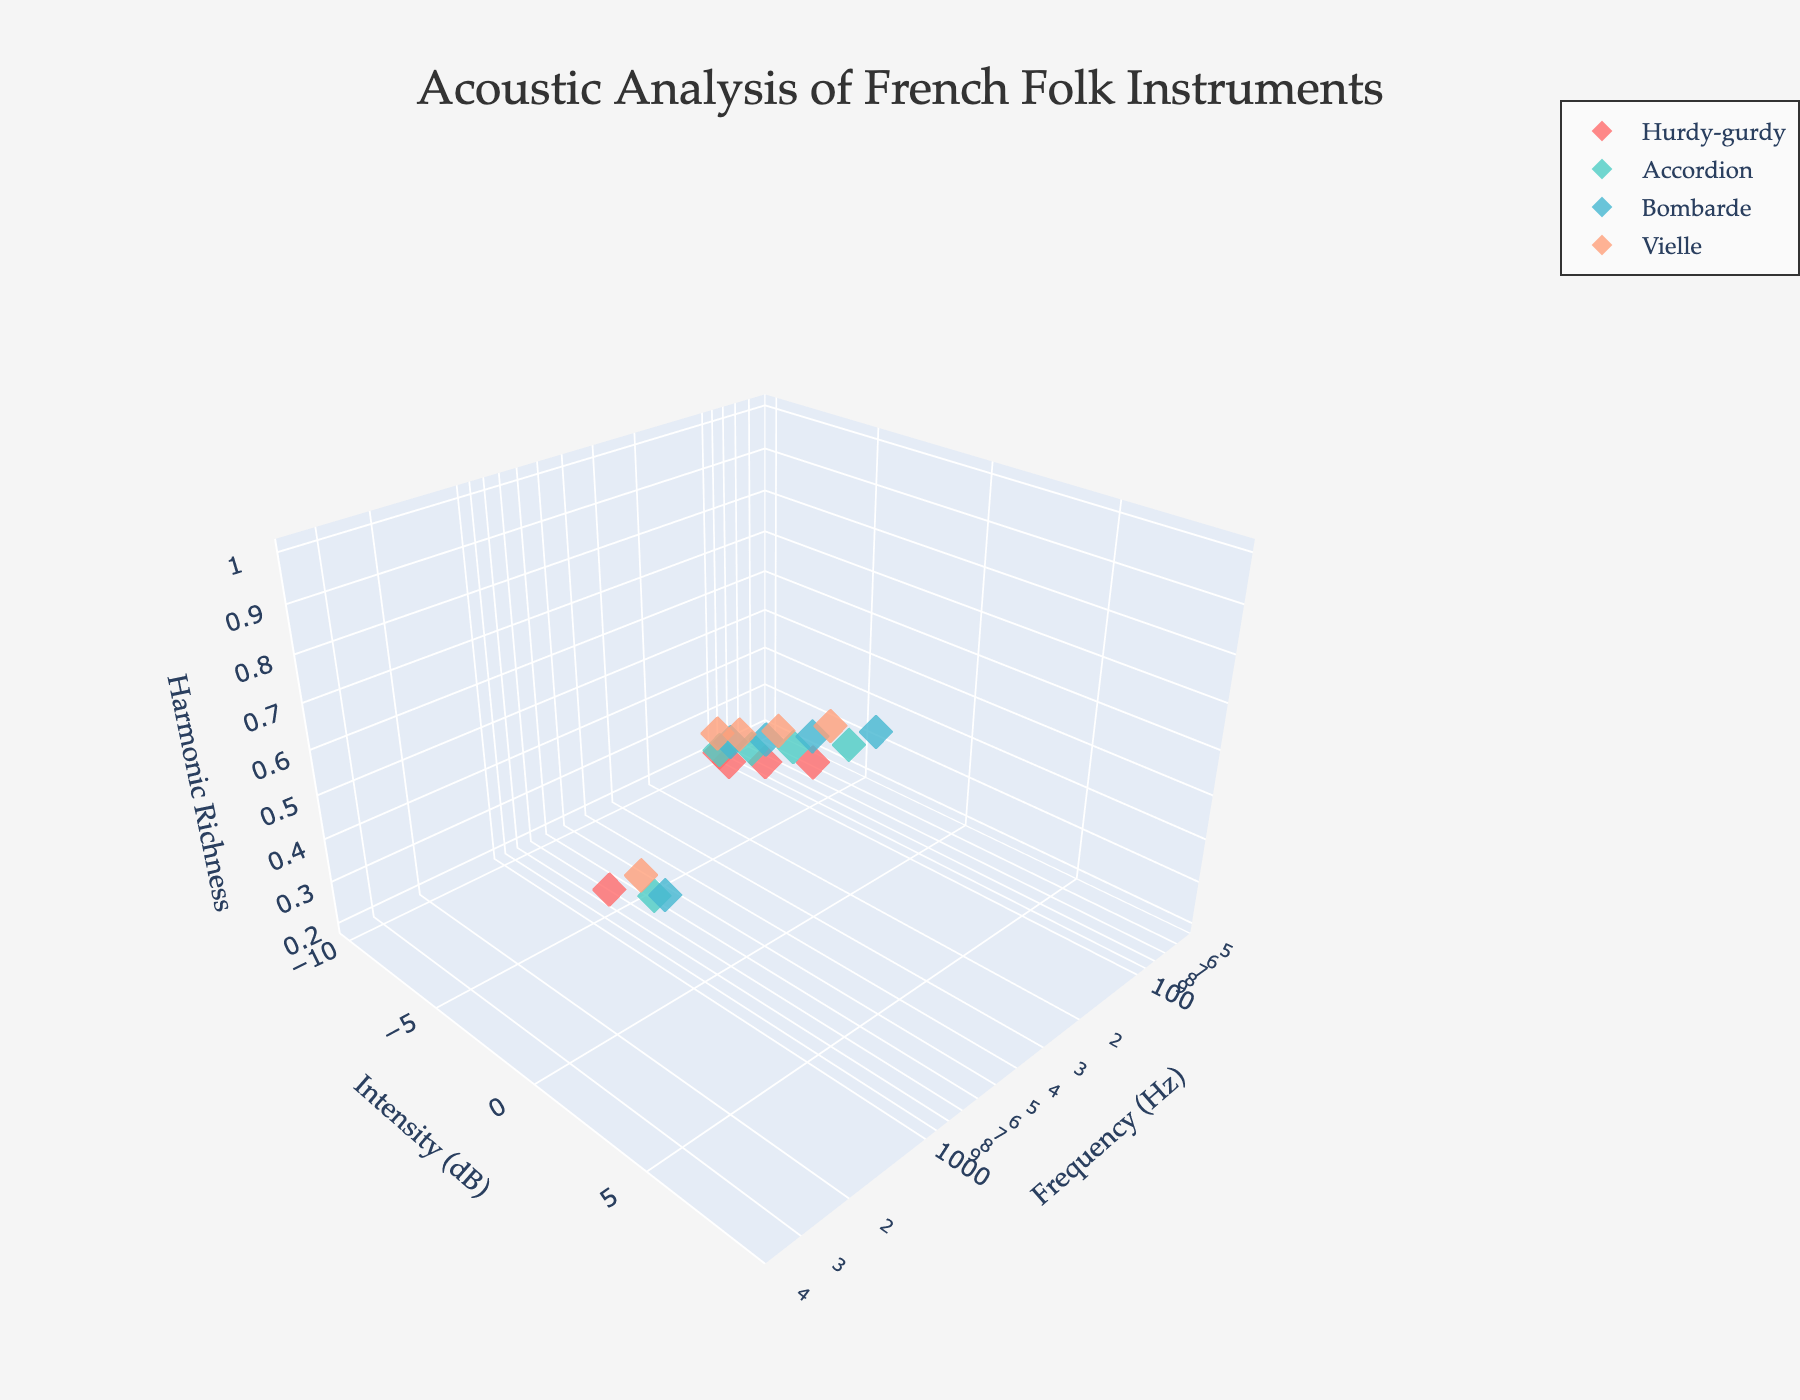What is the title of the 3D volume plot? The title is displayed at the top center of the plot. By reading it, we know the title is "Acoustic Analysis of French Folk Instruments".
Answer: Acoustic Analysis of French Folk Instruments How many data points does each instrument have? Examine each instrument in the plot and count the markers. Each instrument has the following number of data points: Hurdy-gurdy (5), Accordion (5), Bombarde (5), Vielle (5).
Answer: 5 data points each Which instrument shows the richest harmonic profiles at 1200 Hz? Look at the data points around 1200 Hz and identify the instrument. The Accordion has a data point at 1200 Hz with a harmonic richness of 0.9.
Answer: Accordion Compare the maximum harmonic richness achieved by the Bombarde and the Hurdy-gurdy. Which is higher? Find the maximum harmonic richness values for both Bombarde and Hurdy-gurdy in the plot. Bombarde's maximum harmonic richness is 1.0, while Hurdy-gurdy's is 0.8.
Answer: Bombarde At what frequency range do the instruments display the highest harmonic richness overall? Examine the z-axis and see where the highest harmonic richness values cluster. They are mostly around 1000-1600 Hz.
Answer: 1000-1600 Hz Which instrument has the highest harmonic richness at an intensity of 5 dB? Check the plot for the data points around 5 dB intensity and find the instrument with the highest harmonic richness at that intensity. Both the Hurdy-gurdy and Bombarde have data points at 5 dB; Bombarde has a value of 0.7 while Hurdy-gurdy has 0.8.
Answer: Hurdy-gurdy Do any of the instruments have negative intensity values for their data points? Observe the Y-axis (Intensity in dB) and check for negative values associated with any instrument. Most instruments, including Hurdy-gurdy, Accordion, Bombarde, and Vielle, have negative intensities in some of their data points.
Answer: Yes What's the difference in harmonic richness between the Vielle and Accordion at around 1000 Hz? Compare the harmonic richness at approximately 1000 Hz for both instruments. The Vielle is at 1100 Hz with a harmonic richness of 0.9, and the Accordion is at 1200 Hz with a harmonic richness of 0.9, so the difference is 0.
Answer: 0 Which instrument has the broadest frequency range? Examine the x-axis for each instrument and determine the span of frequencies. The Bombarde ranges from 200 Hz to 3200 Hz, which is the widest frequency range.
Answer: Bombarde Which instrument achieves a harmonic richness of 0.7 first as the frequency increases? Identify the harmonic richness of 0.7 and see which instrument reaches this value at the lowest frequency. The Accordion reaches 0.7 at 600 Hz, while the Hurdy-gurdy, Bombarde, and Vielle reach 0.7 at higher frequencies.
Answer: Accordion 